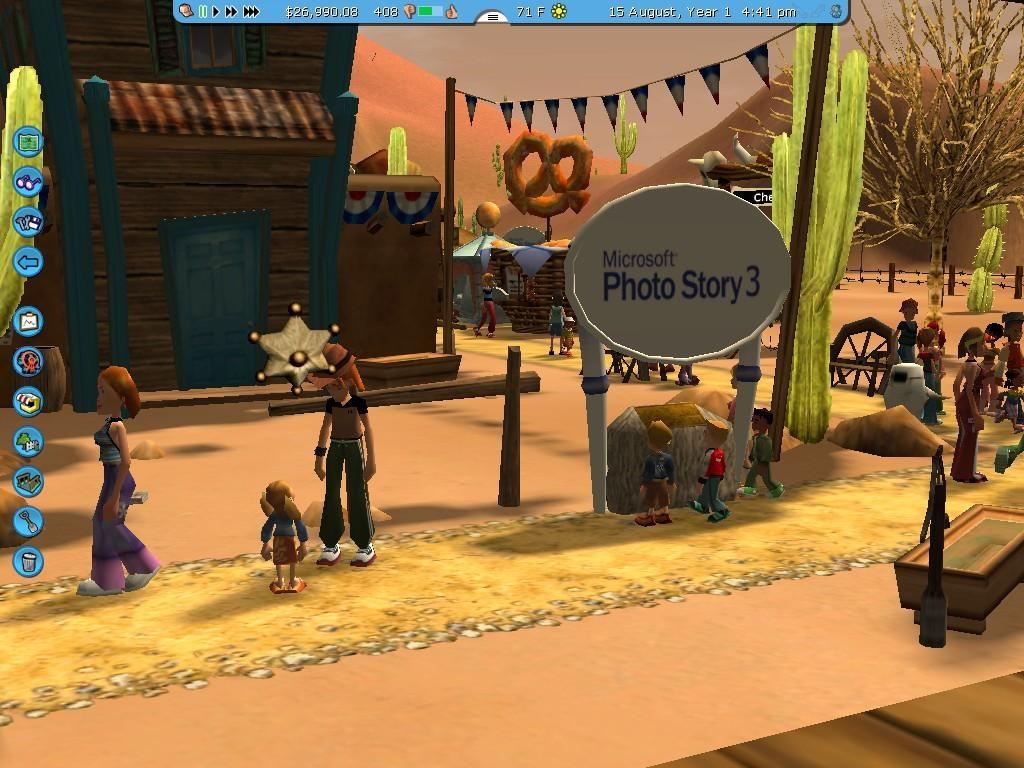What type of characters are present in the image? There are animated people in the image. What other animated elements can be seen in the image? There are animated trees, houses, boards, and hills in the image. Can you describe the background of the image? There is a wire fence in the background of the image. How many nails can be seen in the image? There are no nails present in the image, as it features animated elements rather than real-life objects. 